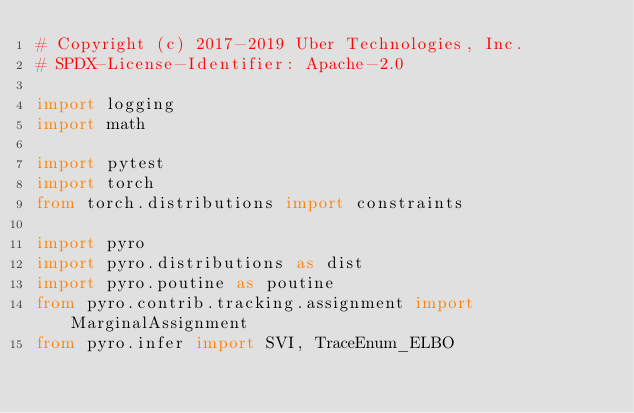Convert code to text. <code><loc_0><loc_0><loc_500><loc_500><_Python_># Copyright (c) 2017-2019 Uber Technologies, Inc.
# SPDX-License-Identifier: Apache-2.0

import logging
import math

import pytest
import torch
from torch.distributions import constraints

import pyro
import pyro.distributions as dist
import pyro.poutine as poutine
from pyro.contrib.tracking.assignment import MarginalAssignment
from pyro.infer import SVI, TraceEnum_ELBO</code> 